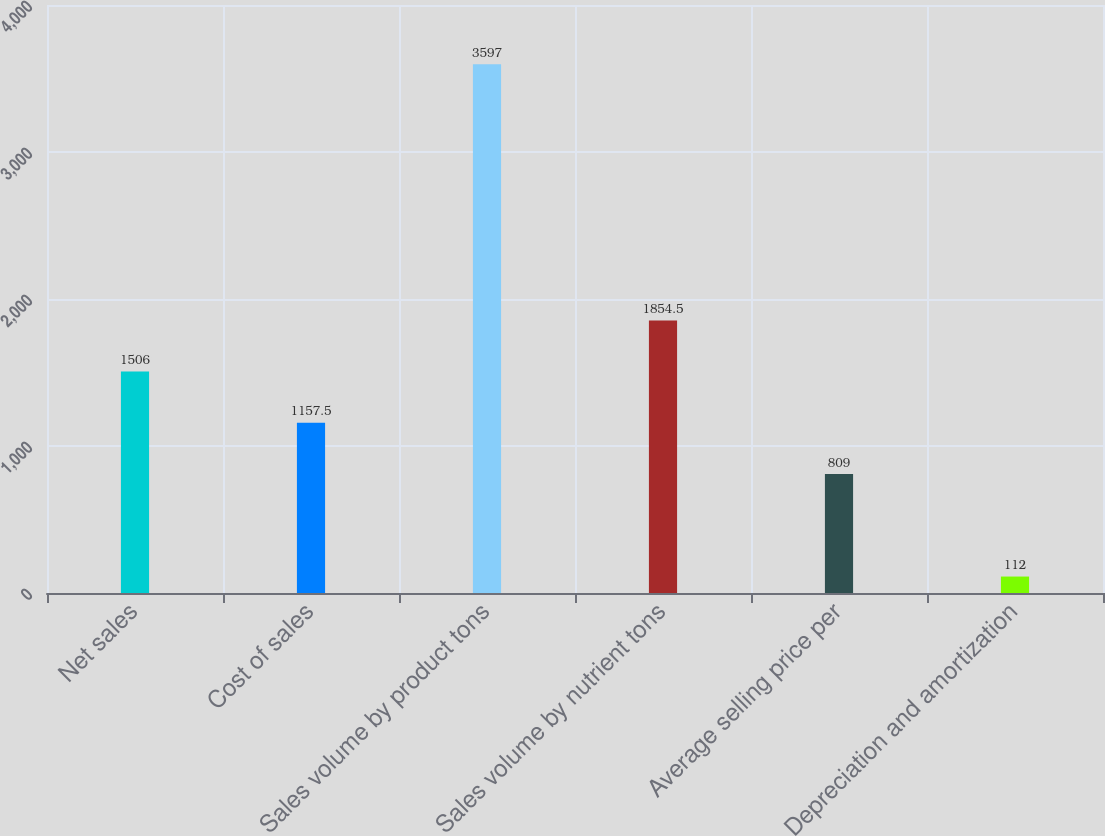Convert chart. <chart><loc_0><loc_0><loc_500><loc_500><bar_chart><fcel>Net sales<fcel>Cost of sales<fcel>Sales volume by product tons<fcel>Sales volume by nutrient tons<fcel>Average selling price per<fcel>Depreciation and amortization<nl><fcel>1506<fcel>1157.5<fcel>3597<fcel>1854.5<fcel>809<fcel>112<nl></chart> 